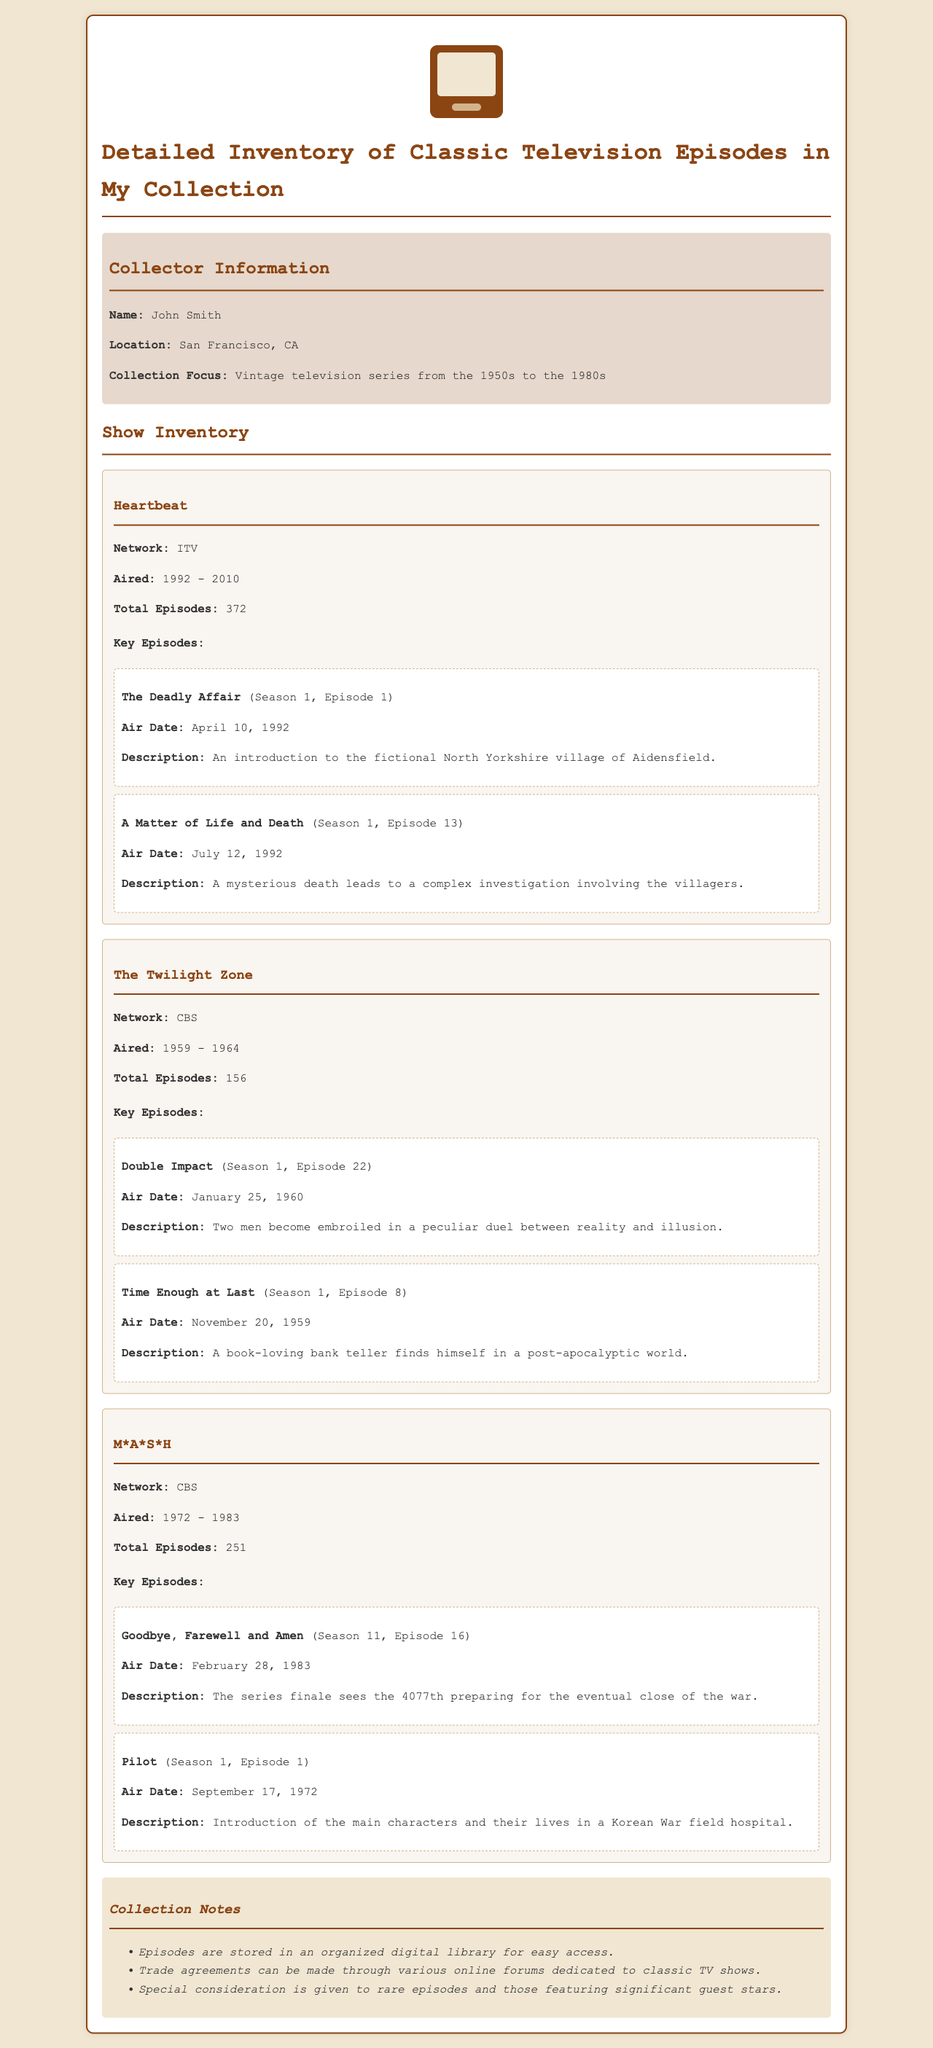What is the collector's name? The collector's name is mentioned in the collector information section of the document.
Answer: John Smith What network aired Heartbeat? The network information for Heartbeat is provided under the show details.
Answer: ITV How many episodes did M*A*S*H have? The total episodes for M*A*S*H are specified in the show inventory section of the document.
Answer: 251 What is the air date of the pilot episode of M*A*S*H? The air date for the pilot episode is listed alongside the episode details.
Answer: September 17, 1972 Which episode of The Twilight Zone aired on January 25, 1960? The air date is matched with episode titles in the episodes section for The Twilight Zone.
Answer: Double Impact What is the total number of episodes for The Twilight Zone? The document states the total episodes under the show details for The Twilight Zone.
Answer: 156 Which season and episode is "The Deadly Affair"? The specific season and episode number are provided in the episode details for Heartbeat.
Answer: Season 1, Episode 1 What special consideration is mentioned in the collection notes? The collection notes detail specific types of episodes that receive special attention.
Answer: Rare episodes What years did Heartbeat air? The airing years for Heartbeat are provided in the show inventory section of the document.
Answer: 1992 - 2010 